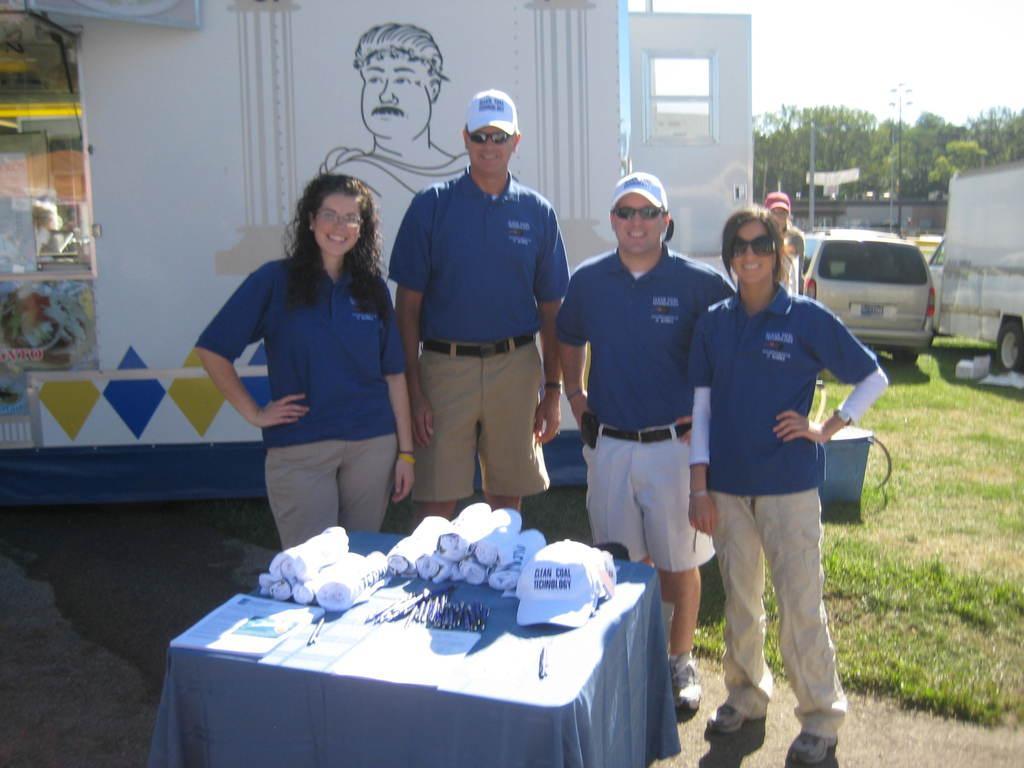In one or two sentences, can you explain what this image depicts? In this image, In the middle there is a table covered by blue cloth on that table there are white color clothes and there is a hat in white color, There are some people standing around the table, In the background there are cars and there is a white color wall there is a man on the wall. 